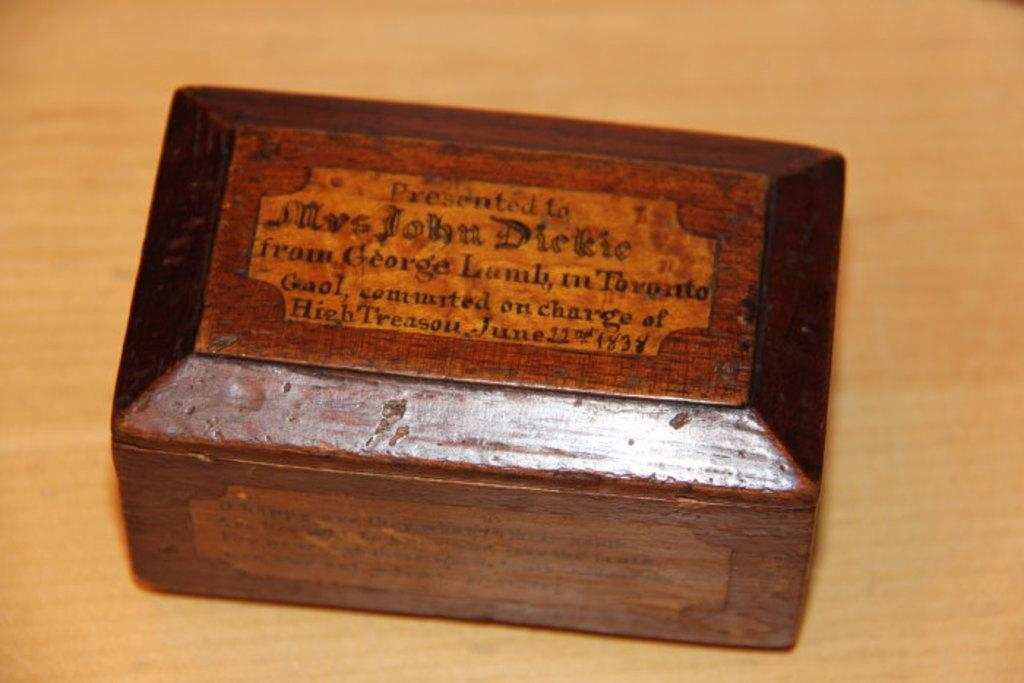Provide a one-sentence caption for the provided image. A wooden box bears the name Mrs. John Dickie. 